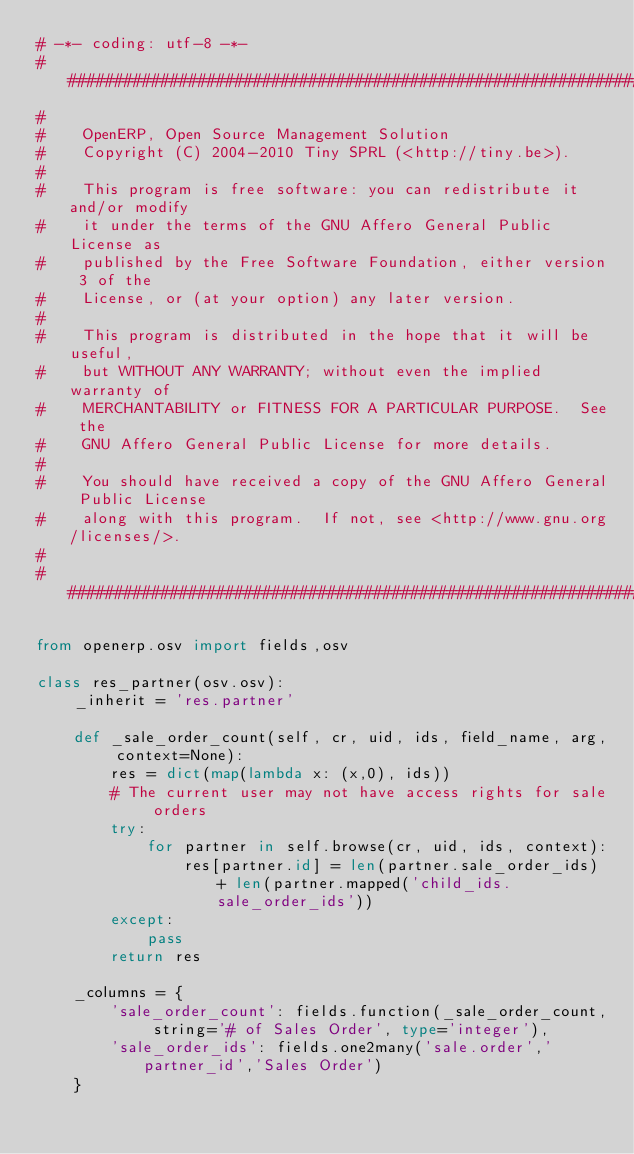Convert code to text. <code><loc_0><loc_0><loc_500><loc_500><_Python_># -*- coding: utf-8 -*-
##############################################################################
#
#    OpenERP, Open Source Management Solution
#    Copyright (C) 2004-2010 Tiny SPRL (<http://tiny.be>).
#
#    This program is free software: you can redistribute it and/or modify
#    it under the terms of the GNU Affero General Public License as
#    published by the Free Software Foundation, either version 3 of the
#    License, or (at your option) any later version.
#
#    This program is distributed in the hope that it will be useful,
#    but WITHOUT ANY WARRANTY; without even the implied warranty of
#    MERCHANTABILITY or FITNESS FOR A PARTICULAR PURPOSE.  See the
#    GNU Affero General Public License for more details.
#
#    You should have received a copy of the GNU Affero General Public License
#    along with this program.  If not, see <http://www.gnu.org/licenses/>.
#
##############################################################################

from openerp.osv import fields,osv

class res_partner(osv.osv):
    _inherit = 'res.partner'

    def _sale_order_count(self, cr, uid, ids, field_name, arg, context=None):
        res = dict(map(lambda x: (x,0), ids))
        # The current user may not have access rights for sale orders
        try:
            for partner in self.browse(cr, uid, ids, context):
                res[partner.id] = len(partner.sale_order_ids) + len(partner.mapped('child_ids.sale_order_ids'))
        except:
            pass
        return res

    _columns = {
        'sale_order_count': fields.function(_sale_order_count, string='# of Sales Order', type='integer'),
        'sale_order_ids': fields.one2many('sale.order','partner_id','Sales Order')
    }

</code> 